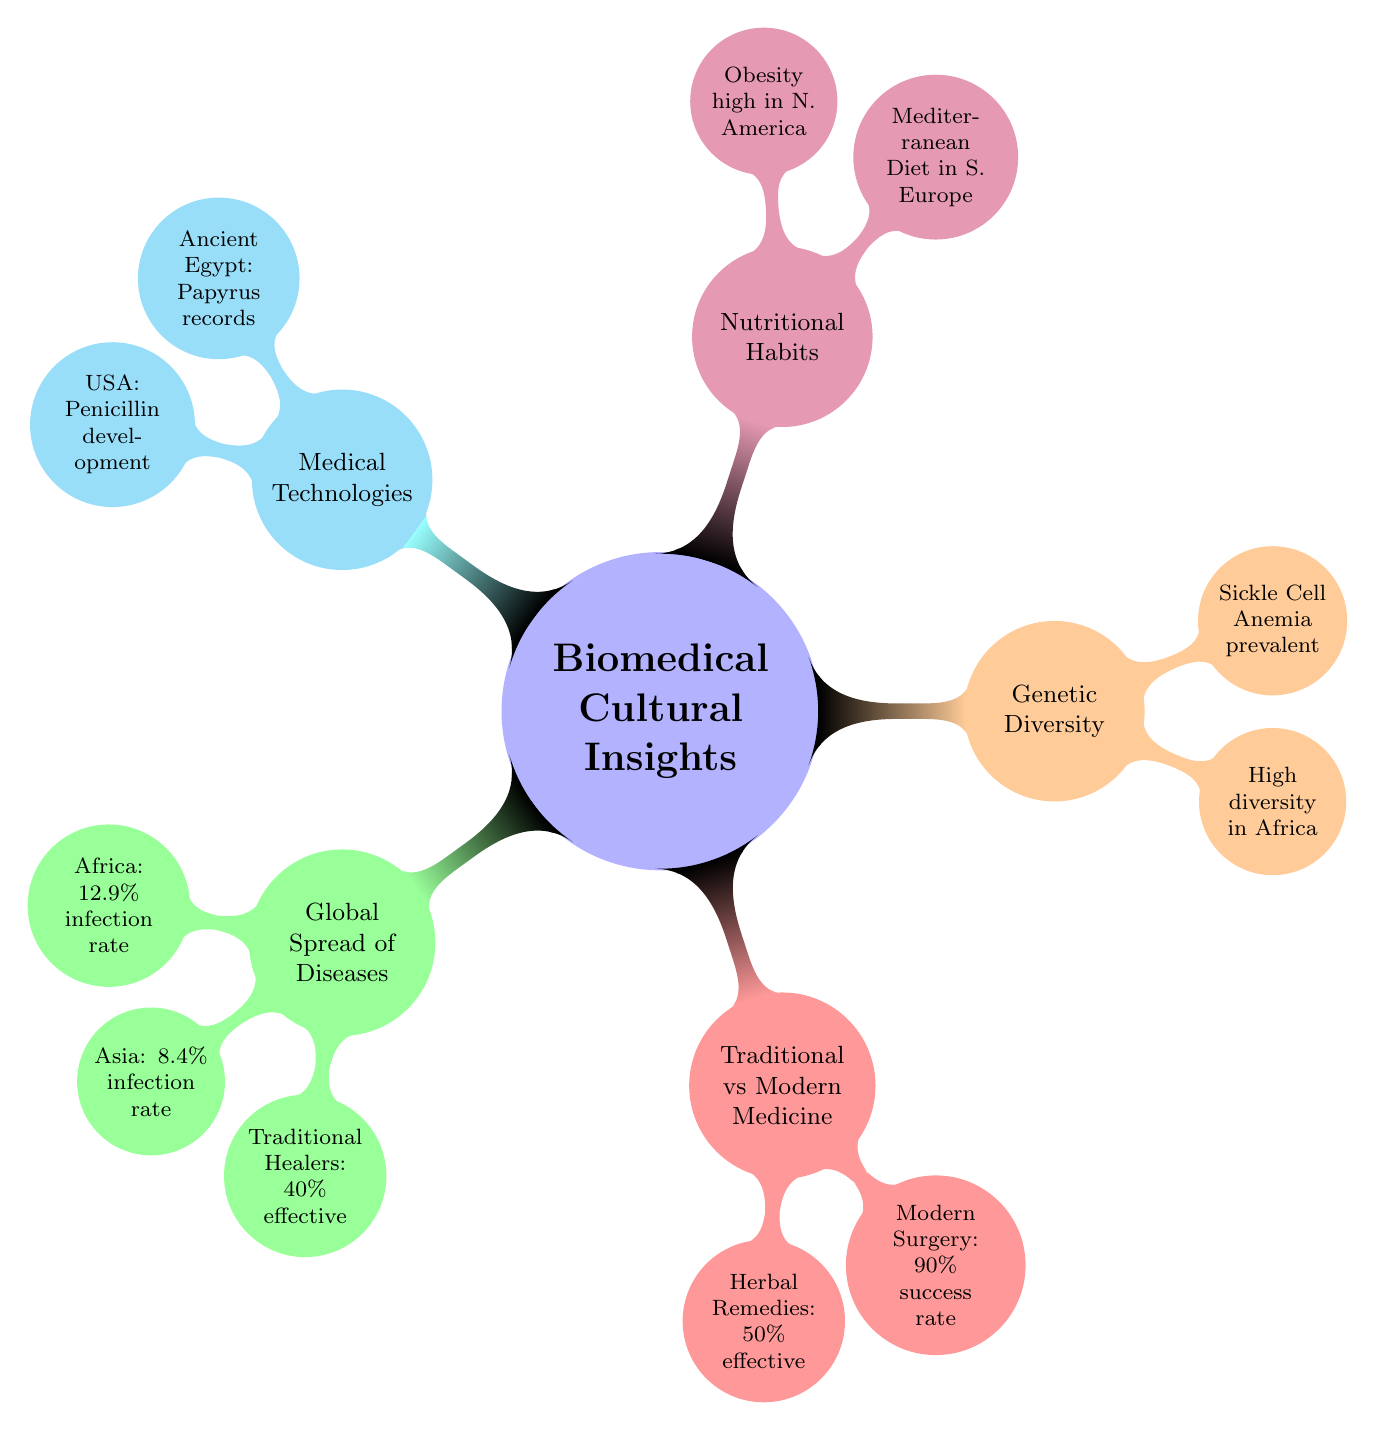What is the infection rate in Africa? The diagram explicitly states that Africa has a 12.9% infection rate listed under the "Global Spread of Diseases" section.
Answer: 12.9% What is the effectiveness rate of traditional healers? The diagram provides information that traditional healers are cited as 40% effective in treating infections.
Answer: 40% What is the success rate of modern surgery? According to the diagram, modern surgery is presented with a success rate of 90%, found in the "Traditional vs Modern Medicine" section.
Answer: 90% Which diet is noted in Southern Europe? The diagram references the Mediterranean diet under the "Nutritional Habits" section, specifically in Southern Europe.
Answer: Mediterranean Diet What is prevalent in areas with high genetic diversity? The diagram indicates that Sickle Cell Anemia is prevalent in regions with high genetic diversity, specifically in the context of Africa.
Answer: Sickle Cell Anemia In which country was penicillin developed? The diagram details under "Medical Technologies" that penicillin was developed in the USA.
Answer: USA What comparison can be made between the effectiveness of herbal remedies and traditional healers? The diagram shows that herbal remedies are 50% effective while traditional healers are 40% effective, suggesting that herbal remedies are more effective.
Answer: Herbal Remedies are more effective What relationship exists between dietary patterns and health conditions in North America? The diagram presents a clear link indicating high obesity rates in North America under the "Nutritional Habits" section, suggesting poor health outcomes related to dietary patterns.
Answer: High obesity rates How does the ancient Egyptian contribution relate to medical records? The diagram states that Ancient Egypt contributed with papyrus records under "Medical Technologies," indicating their historical role in documenting medical knowledge.
Answer: Papyrus records What does the diagram suggest about cultural influences on treatment methods? The diagram illustrates varying effectiveness of treatment methods, such as traditional healing practices and modern surgical techniques, highlighting the cultural influences pervasive in healthcare.
Answer: Cultural influences are significant 